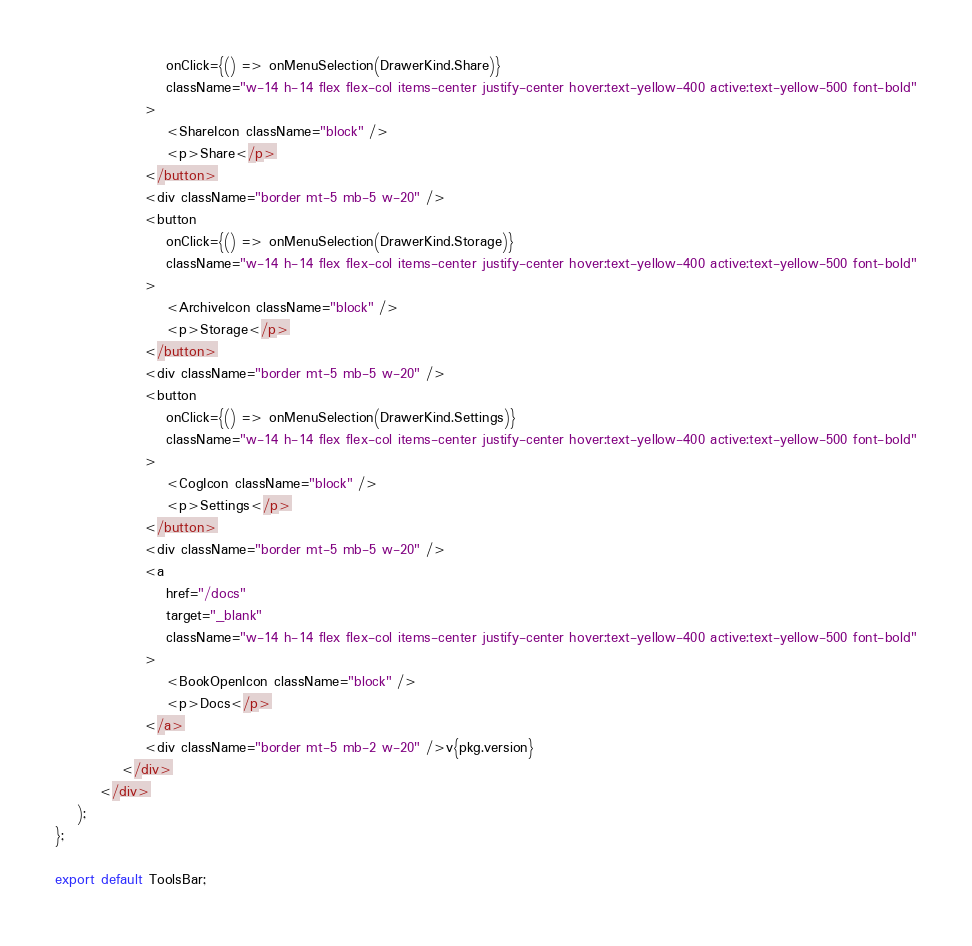Convert code to text. <code><loc_0><loc_0><loc_500><loc_500><_TypeScript_>                    onClick={() => onMenuSelection(DrawerKind.Share)}
                    className="w-14 h-14 flex flex-col items-center justify-center hover:text-yellow-400 active:text-yellow-500 font-bold"
                >
                    <ShareIcon className="block" />
                    <p>Share</p>
                </button>
                <div className="border mt-5 mb-5 w-20" />
                <button
                    onClick={() => onMenuSelection(DrawerKind.Storage)}
                    className="w-14 h-14 flex flex-col items-center justify-center hover:text-yellow-400 active:text-yellow-500 font-bold"
                >
                    <ArchiveIcon className="block" />
                    <p>Storage</p>
                </button>
                <div className="border mt-5 mb-5 w-20" />
                <button
                    onClick={() => onMenuSelection(DrawerKind.Settings)}
                    className="w-14 h-14 flex flex-col items-center justify-center hover:text-yellow-400 active:text-yellow-500 font-bold"
                >
                    <CogIcon className="block" />
                    <p>Settings</p>
                </button>
                <div className="border mt-5 mb-5 w-20" />
                <a
                    href="/docs"
                    target="_blank"
                    className="w-14 h-14 flex flex-col items-center justify-center hover:text-yellow-400 active:text-yellow-500 font-bold"
                >
                    <BookOpenIcon className="block" />
                    <p>Docs</p>
                </a>
                <div className="border mt-5 mb-2 w-20" />v{pkg.version}
            </div>
        </div>
    );
};

export default ToolsBar;
</code> 